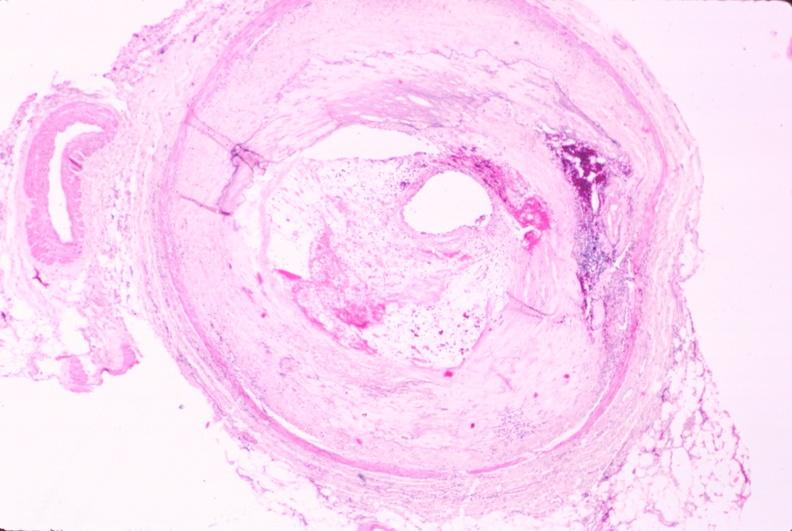what is atherosclerosis left?
Answer the question using a single word or phrase. Anterior descending coronary artery 